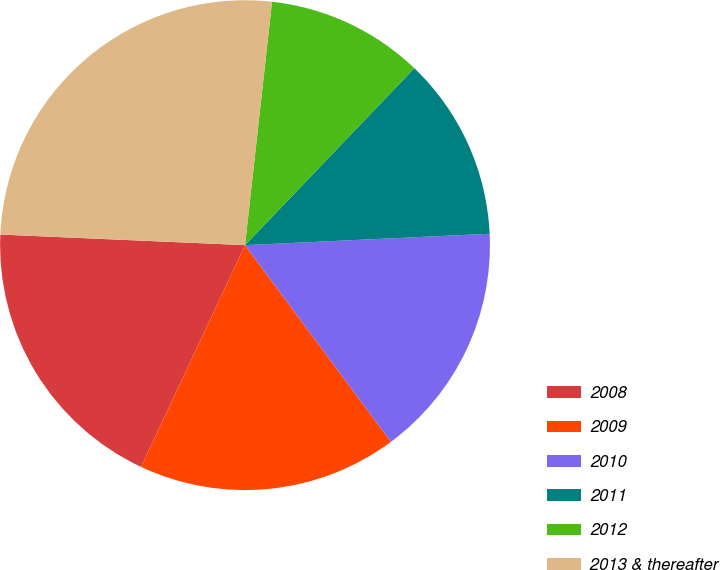Convert chart to OTSL. <chart><loc_0><loc_0><loc_500><loc_500><pie_chart><fcel>2008<fcel>2009<fcel>2010<fcel>2011<fcel>2012<fcel>2013 & thereafter<nl><fcel>18.71%<fcel>17.14%<fcel>15.58%<fcel>12.11%<fcel>10.39%<fcel>26.07%<nl></chart> 